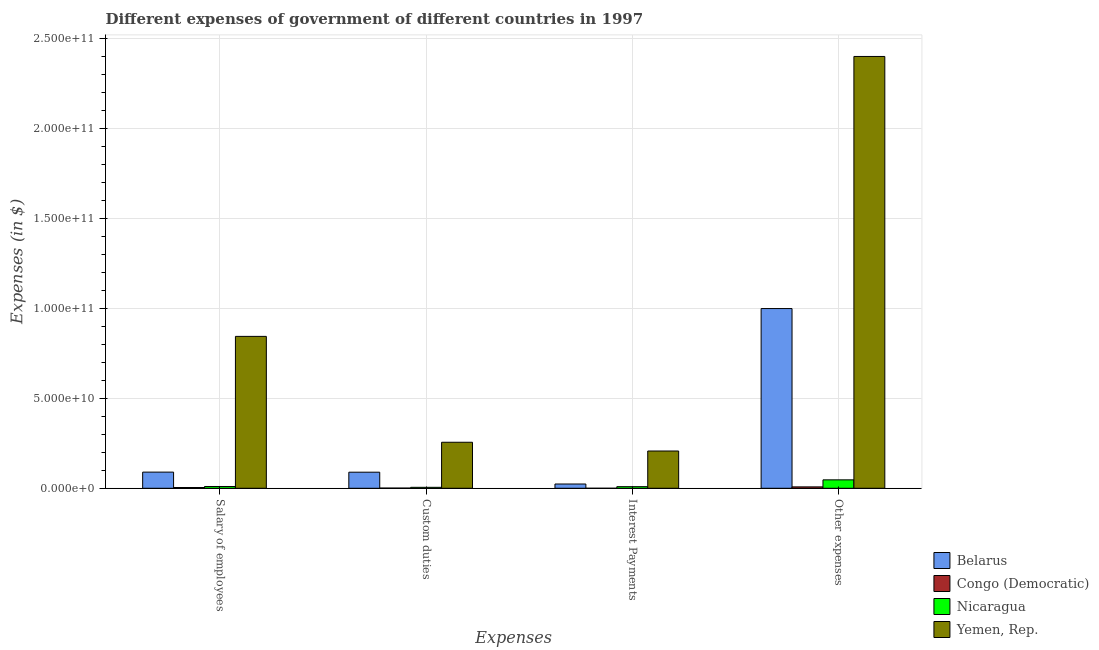Are the number of bars per tick equal to the number of legend labels?
Your answer should be very brief. Yes. What is the label of the 2nd group of bars from the left?
Offer a terse response. Custom duties. What is the amount spent on custom duties in Belarus?
Your answer should be very brief. 8.93e+09. Across all countries, what is the maximum amount spent on salary of employees?
Ensure brevity in your answer.  8.44e+1. Across all countries, what is the minimum amount spent on salary of employees?
Your answer should be very brief. 4.29e+08. In which country was the amount spent on salary of employees maximum?
Give a very brief answer. Yemen, Rep. In which country was the amount spent on salary of employees minimum?
Offer a very short reply. Congo (Democratic). What is the total amount spent on salary of employees in the graph?
Offer a terse response. 9.48e+1. What is the difference between the amount spent on other expenses in Nicaragua and that in Congo (Democratic)?
Offer a terse response. 3.91e+09. What is the difference between the amount spent on salary of employees in Congo (Democratic) and the amount spent on custom duties in Nicaragua?
Your answer should be compact. -1.08e+08. What is the average amount spent on salary of employees per country?
Ensure brevity in your answer.  2.37e+1. What is the difference between the amount spent on custom duties and amount spent on interest payments in Yemen, Rep.?
Offer a terse response. 4.86e+09. What is the ratio of the amount spent on custom duties in Nicaragua to that in Congo (Democratic)?
Your answer should be very brief. 5.1. Is the difference between the amount spent on salary of employees in Congo (Democratic) and Yemen, Rep. greater than the difference between the amount spent on custom duties in Congo (Democratic) and Yemen, Rep.?
Keep it short and to the point. No. What is the difference between the highest and the second highest amount spent on interest payments?
Offer a very short reply. 1.83e+1. What is the difference between the highest and the lowest amount spent on custom duties?
Give a very brief answer. 2.55e+1. What does the 3rd bar from the left in Salary of employees represents?
Make the answer very short. Nicaragua. What does the 4th bar from the right in Salary of employees represents?
Give a very brief answer. Belarus. Is it the case that in every country, the sum of the amount spent on salary of employees and amount spent on custom duties is greater than the amount spent on interest payments?
Your answer should be very brief. Yes. How many countries are there in the graph?
Offer a terse response. 4. Are the values on the major ticks of Y-axis written in scientific E-notation?
Offer a terse response. Yes. Does the graph contain any zero values?
Give a very brief answer. No. Does the graph contain grids?
Your answer should be compact. Yes. Where does the legend appear in the graph?
Provide a short and direct response. Bottom right. How many legend labels are there?
Your answer should be very brief. 4. How are the legend labels stacked?
Your answer should be compact. Vertical. What is the title of the graph?
Ensure brevity in your answer.  Different expenses of government of different countries in 1997. What is the label or title of the X-axis?
Make the answer very short. Expenses. What is the label or title of the Y-axis?
Your answer should be very brief. Expenses (in $). What is the Expenses (in $) in Belarus in Salary of employees?
Your answer should be compact. 8.98e+09. What is the Expenses (in $) of Congo (Democratic) in Salary of employees?
Your answer should be compact. 4.29e+08. What is the Expenses (in $) of Nicaragua in Salary of employees?
Provide a short and direct response. 9.96e+08. What is the Expenses (in $) in Yemen, Rep. in Salary of employees?
Provide a succinct answer. 8.44e+1. What is the Expenses (in $) of Belarus in Custom duties?
Provide a short and direct response. 8.93e+09. What is the Expenses (in $) in Congo (Democratic) in Custom duties?
Give a very brief answer. 1.05e+08. What is the Expenses (in $) in Nicaragua in Custom duties?
Provide a short and direct response. 5.37e+08. What is the Expenses (in $) of Yemen, Rep. in Custom duties?
Offer a terse response. 2.56e+1. What is the Expenses (in $) of Belarus in Interest Payments?
Provide a succinct answer. 2.37e+09. What is the Expenses (in $) in Nicaragua in Interest Payments?
Offer a terse response. 8.99e+08. What is the Expenses (in $) in Yemen, Rep. in Interest Payments?
Ensure brevity in your answer.  2.07e+1. What is the Expenses (in $) of Belarus in Other expenses?
Keep it short and to the point. 9.98e+1. What is the Expenses (in $) of Congo (Democratic) in Other expenses?
Provide a short and direct response. 7.77e+08. What is the Expenses (in $) in Nicaragua in Other expenses?
Offer a very short reply. 4.68e+09. What is the Expenses (in $) of Yemen, Rep. in Other expenses?
Keep it short and to the point. 2.40e+11. Across all Expenses, what is the maximum Expenses (in $) in Belarus?
Your answer should be compact. 9.98e+1. Across all Expenses, what is the maximum Expenses (in $) of Congo (Democratic)?
Provide a short and direct response. 7.77e+08. Across all Expenses, what is the maximum Expenses (in $) in Nicaragua?
Your response must be concise. 4.68e+09. Across all Expenses, what is the maximum Expenses (in $) of Yemen, Rep.?
Your answer should be very brief. 2.40e+11. Across all Expenses, what is the minimum Expenses (in $) of Belarus?
Give a very brief answer. 2.37e+09. Across all Expenses, what is the minimum Expenses (in $) of Congo (Democratic)?
Keep it short and to the point. 8.00e+05. Across all Expenses, what is the minimum Expenses (in $) of Nicaragua?
Offer a terse response. 5.37e+08. Across all Expenses, what is the minimum Expenses (in $) of Yemen, Rep.?
Your response must be concise. 2.07e+1. What is the total Expenses (in $) in Belarus in the graph?
Provide a succinct answer. 1.20e+11. What is the total Expenses (in $) of Congo (Democratic) in the graph?
Your response must be concise. 1.31e+09. What is the total Expenses (in $) of Nicaragua in the graph?
Provide a succinct answer. 7.12e+09. What is the total Expenses (in $) in Yemen, Rep. in the graph?
Make the answer very short. 3.71e+11. What is the difference between the Expenses (in $) in Belarus in Salary of employees and that in Custom duties?
Offer a terse response. 4.52e+07. What is the difference between the Expenses (in $) of Congo (Democratic) in Salary of employees and that in Custom duties?
Make the answer very short. 3.23e+08. What is the difference between the Expenses (in $) of Nicaragua in Salary of employees and that in Custom duties?
Make the answer very short. 4.59e+08. What is the difference between the Expenses (in $) in Yemen, Rep. in Salary of employees and that in Custom duties?
Ensure brevity in your answer.  5.88e+1. What is the difference between the Expenses (in $) of Belarus in Salary of employees and that in Interest Payments?
Your response must be concise. 6.61e+09. What is the difference between the Expenses (in $) in Congo (Democratic) in Salary of employees and that in Interest Payments?
Offer a terse response. 4.28e+08. What is the difference between the Expenses (in $) in Nicaragua in Salary of employees and that in Interest Payments?
Provide a short and direct response. 9.75e+07. What is the difference between the Expenses (in $) in Yemen, Rep. in Salary of employees and that in Interest Payments?
Offer a very short reply. 6.37e+1. What is the difference between the Expenses (in $) in Belarus in Salary of employees and that in Other expenses?
Your response must be concise. -9.09e+1. What is the difference between the Expenses (in $) of Congo (Democratic) in Salary of employees and that in Other expenses?
Provide a succinct answer. -3.48e+08. What is the difference between the Expenses (in $) of Nicaragua in Salary of employees and that in Other expenses?
Keep it short and to the point. -3.69e+09. What is the difference between the Expenses (in $) of Yemen, Rep. in Salary of employees and that in Other expenses?
Keep it short and to the point. -1.55e+11. What is the difference between the Expenses (in $) of Belarus in Custom duties and that in Interest Payments?
Offer a very short reply. 6.56e+09. What is the difference between the Expenses (in $) of Congo (Democratic) in Custom duties and that in Interest Payments?
Ensure brevity in your answer.  1.05e+08. What is the difference between the Expenses (in $) in Nicaragua in Custom duties and that in Interest Payments?
Ensure brevity in your answer.  -3.62e+08. What is the difference between the Expenses (in $) in Yemen, Rep. in Custom duties and that in Interest Payments?
Provide a succinct answer. 4.86e+09. What is the difference between the Expenses (in $) in Belarus in Custom duties and that in Other expenses?
Ensure brevity in your answer.  -9.09e+1. What is the difference between the Expenses (in $) of Congo (Democratic) in Custom duties and that in Other expenses?
Ensure brevity in your answer.  -6.71e+08. What is the difference between the Expenses (in $) of Nicaragua in Custom duties and that in Other expenses?
Your answer should be very brief. -4.15e+09. What is the difference between the Expenses (in $) of Yemen, Rep. in Custom duties and that in Other expenses?
Provide a succinct answer. -2.14e+11. What is the difference between the Expenses (in $) of Belarus in Interest Payments and that in Other expenses?
Your response must be concise. -9.75e+1. What is the difference between the Expenses (in $) of Congo (Democratic) in Interest Payments and that in Other expenses?
Provide a succinct answer. -7.76e+08. What is the difference between the Expenses (in $) in Nicaragua in Interest Payments and that in Other expenses?
Make the answer very short. -3.79e+09. What is the difference between the Expenses (in $) in Yemen, Rep. in Interest Payments and that in Other expenses?
Offer a very short reply. -2.19e+11. What is the difference between the Expenses (in $) of Belarus in Salary of employees and the Expenses (in $) of Congo (Democratic) in Custom duties?
Provide a short and direct response. 8.87e+09. What is the difference between the Expenses (in $) of Belarus in Salary of employees and the Expenses (in $) of Nicaragua in Custom duties?
Provide a short and direct response. 8.44e+09. What is the difference between the Expenses (in $) of Belarus in Salary of employees and the Expenses (in $) of Yemen, Rep. in Custom duties?
Your answer should be compact. -1.66e+1. What is the difference between the Expenses (in $) in Congo (Democratic) in Salary of employees and the Expenses (in $) in Nicaragua in Custom duties?
Your response must be concise. -1.08e+08. What is the difference between the Expenses (in $) of Congo (Democratic) in Salary of employees and the Expenses (in $) of Yemen, Rep. in Custom duties?
Make the answer very short. -2.51e+1. What is the difference between the Expenses (in $) of Nicaragua in Salary of employees and the Expenses (in $) of Yemen, Rep. in Custom duties?
Offer a very short reply. -2.46e+1. What is the difference between the Expenses (in $) in Belarus in Salary of employees and the Expenses (in $) in Congo (Democratic) in Interest Payments?
Make the answer very short. 8.98e+09. What is the difference between the Expenses (in $) of Belarus in Salary of employees and the Expenses (in $) of Nicaragua in Interest Payments?
Offer a terse response. 8.08e+09. What is the difference between the Expenses (in $) of Belarus in Salary of employees and the Expenses (in $) of Yemen, Rep. in Interest Payments?
Give a very brief answer. -1.17e+1. What is the difference between the Expenses (in $) in Congo (Democratic) in Salary of employees and the Expenses (in $) in Nicaragua in Interest Payments?
Your response must be concise. -4.70e+08. What is the difference between the Expenses (in $) of Congo (Democratic) in Salary of employees and the Expenses (in $) of Yemen, Rep. in Interest Payments?
Your answer should be compact. -2.03e+1. What is the difference between the Expenses (in $) in Nicaragua in Salary of employees and the Expenses (in $) in Yemen, Rep. in Interest Payments?
Offer a terse response. -1.97e+1. What is the difference between the Expenses (in $) in Belarus in Salary of employees and the Expenses (in $) in Congo (Democratic) in Other expenses?
Provide a short and direct response. 8.20e+09. What is the difference between the Expenses (in $) in Belarus in Salary of employees and the Expenses (in $) in Nicaragua in Other expenses?
Your answer should be compact. 4.29e+09. What is the difference between the Expenses (in $) in Belarus in Salary of employees and the Expenses (in $) in Yemen, Rep. in Other expenses?
Make the answer very short. -2.31e+11. What is the difference between the Expenses (in $) of Congo (Democratic) in Salary of employees and the Expenses (in $) of Nicaragua in Other expenses?
Provide a short and direct response. -4.26e+09. What is the difference between the Expenses (in $) of Congo (Democratic) in Salary of employees and the Expenses (in $) of Yemen, Rep. in Other expenses?
Offer a terse response. -2.39e+11. What is the difference between the Expenses (in $) in Nicaragua in Salary of employees and the Expenses (in $) in Yemen, Rep. in Other expenses?
Keep it short and to the point. -2.39e+11. What is the difference between the Expenses (in $) in Belarus in Custom duties and the Expenses (in $) in Congo (Democratic) in Interest Payments?
Make the answer very short. 8.93e+09. What is the difference between the Expenses (in $) of Belarus in Custom duties and the Expenses (in $) of Nicaragua in Interest Payments?
Make the answer very short. 8.04e+09. What is the difference between the Expenses (in $) in Belarus in Custom duties and the Expenses (in $) in Yemen, Rep. in Interest Payments?
Offer a terse response. -1.18e+1. What is the difference between the Expenses (in $) of Congo (Democratic) in Custom duties and the Expenses (in $) of Nicaragua in Interest Payments?
Make the answer very short. -7.93e+08. What is the difference between the Expenses (in $) of Congo (Democratic) in Custom duties and the Expenses (in $) of Yemen, Rep. in Interest Payments?
Give a very brief answer. -2.06e+1. What is the difference between the Expenses (in $) in Nicaragua in Custom duties and the Expenses (in $) in Yemen, Rep. in Interest Payments?
Your response must be concise. -2.02e+1. What is the difference between the Expenses (in $) of Belarus in Custom duties and the Expenses (in $) of Congo (Democratic) in Other expenses?
Provide a succinct answer. 8.16e+09. What is the difference between the Expenses (in $) in Belarus in Custom duties and the Expenses (in $) in Nicaragua in Other expenses?
Ensure brevity in your answer.  4.25e+09. What is the difference between the Expenses (in $) in Belarus in Custom duties and the Expenses (in $) in Yemen, Rep. in Other expenses?
Keep it short and to the point. -2.31e+11. What is the difference between the Expenses (in $) in Congo (Democratic) in Custom duties and the Expenses (in $) in Nicaragua in Other expenses?
Provide a succinct answer. -4.58e+09. What is the difference between the Expenses (in $) in Congo (Democratic) in Custom duties and the Expenses (in $) in Yemen, Rep. in Other expenses?
Keep it short and to the point. -2.40e+11. What is the difference between the Expenses (in $) of Nicaragua in Custom duties and the Expenses (in $) of Yemen, Rep. in Other expenses?
Give a very brief answer. -2.39e+11. What is the difference between the Expenses (in $) in Belarus in Interest Payments and the Expenses (in $) in Congo (Democratic) in Other expenses?
Give a very brief answer. 1.60e+09. What is the difference between the Expenses (in $) of Belarus in Interest Payments and the Expenses (in $) of Nicaragua in Other expenses?
Your answer should be very brief. -2.31e+09. What is the difference between the Expenses (in $) in Belarus in Interest Payments and the Expenses (in $) in Yemen, Rep. in Other expenses?
Your response must be concise. -2.37e+11. What is the difference between the Expenses (in $) in Congo (Democratic) in Interest Payments and the Expenses (in $) in Nicaragua in Other expenses?
Offer a very short reply. -4.68e+09. What is the difference between the Expenses (in $) of Congo (Democratic) in Interest Payments and the Expenses (in $) of Yemen, Rep. in Other expenses?
Your answer should be very brief. -2.40e+11. What is the difference between the Expenses (in $) of Nicaragua in Interest Payments and the Expenses (in $) of Yemen, Rep. in Other expenses?
Offer a terse response. -2.39e+11. What is the average Expenses (in $) of Belarus per Expenses?
Make the answer very short. 3.00e+1. What is the average Expenses (in $) of Congo (Democratic) per Expenses?
Offer a terse response. 3.28e+08. What is the average Expenses (in $) of Nicaragua per Expenses?
Offer a terse response. 1.78e+09. What is the average Expenses (in $) in Yemen, Rep. per Expenses?
Keep it short and to the point. 9.26e+1. What is the difference between the Expenses (in $) in Belarus and Expenses (in $) in Congo (Democratic) in Salary of employees?
Your answer should be very brief. 8.55e+09. What is the difference between the Expenses (in $) of Belarus and Expenses (in $) of Nicaragua in Salary of employees?
Make the answer very short. 7.98e+09. What is the difference between the Expenses (in $) in Belarus and Expenses (in $) in Yemen, Rep. in Salary of employees?
Provide a succinct answer. -7.54e+1. What is the difference between the Expenses (in $) of Congo (Democratic) and Expenses (in $) of Nicaragua in Salary of employees?
Make the answer very short. -5.67e+08. What is the difference between the Expenses (in $) in Congo (Democratic) and Expenses (in $) in Yemen, Rep. in Salary of employees?
Your answer should be very brief. -8.39e+1. What is the difference between the Expenses (in $) in Nicaragua and Expenses (in $) in Yemen, Rep. in Salary of employees?
Make the answer very short. -8.34e+1. What is the difference between the Expenses (in $) of Belarus and Expenses (in $) of Congo (Democratic) in Custom duties?
Your response must be concise. 8.83e+09. What is the difference between the Expenses (in $) of Belarus and Expenses (in $) of Nicaragua in Custom duties?
Ensure brevity in your answer.  8.40e+09. What is the difference between the Expenses (in $) in Belarus and Expenses (in $) in Yemen, Rep. in Custom duties?
Offer a terse response. -1.66e+1. What is the difference between the Expenses (in $) in Congo (Democratic) and Expenses (in $) in Nicaragua in Custom duties?
Provide a succinct answer. -4.31e+08. What is the difference between the Expenses (in $) of Congo (Democratic) and Expenses (in $) of Yemen, Rep. in Custom duties?
Offer a very short reply. -2.55e+1. What is the difference between the Expenses (in $) in Nicaragua and Expenses (in $) in Yemen, Rep. in Custom duties?
Your response must be concise. -2.50e+1. What is the difference between the Expenses (in $) of Belarus and Expenses (in $) of Congo (Democratic) in Interest Payments?
Provide a short and direct response. 2.37e+09. What is the difference between the Expenses (in $) in Belarus and Expenses (in $) in Nicaragua in Interest Payments?
Keep it short and to the point. 1.48e+09. What is the difference between the Expenses (in $) in Belarus and Expenses (in $) in Yemen, Rep. in Interest Payments?
Your answer should be very brief. -1.83e+1. What is the difference between the Expenses (in $) of Congo (Democratic) and Expenses (in $) of Nicaragua in Interest Payments?
Ensure brevity in your answer.  -8.98e+08. What is the difference between the Expenses (in $) of Congo (Democratic) and Expenses (in $) of Yemen, Rep. in Interest Payments?
Provide a short and direct response. -2.07e+1. What is the difference between the Expenses (in $) in Nicaragua and Expenses (in $) in Yemen, Rep. in Interest Payments?
Ensure brevity in your answer.  -1.98e+1. What is the difference between the Expenses (in $) in Belarus and Expenses (in $) in Congo (Democratic) in Other expenses?
Offer a terse response. 9.91e+1. What is the difference between the Expenses (in $) of Belarus and Expenses (in $) of Nicaragua in Other expenses?
Offer a terse response. 9.51e+1. What is the difference between the Expenses (in $) in Belarus and Expenses (in $) in Yemen, Rep. in Other expenses?
Provide a short and direct response. -1.40e+11. What is the difference between the Expenses (in $) of Congo (Democratic) and Expenses (in $) of Nicaragua in Other expenses?
Offer a very short reply. -3.91e+09. What is the difference between the Expenses (in $) of Congo (Democratic) and Expenses (in $) of Yemen, Rep. in Other expenses?
Offer a very short reply. -2.39e+11. What is the difference between the Expenses (in $) in Nicaragua and Expenses (in $) in Yemen, Rep. in Other expenses?
Your response must be concise. -2.35e+11. What is the ratio of the Expenses (in $) in Congo (Democratic) in Salary of employees to that in Custom duties?
Offer a terse response. 4.07. What is the ratio of the Expenses (in $) in Nicaragua in Salary of employees to that in Custom duties?
Offer a terse response. 1.86. What is the ratio of the Expenses (in $) in Yemen, Rep. in Salary of employees to that in Custom duties?
Your answer should be very brief. 3.3. What is the ratio of the Expenses (in $) of Belarus in Salary of employees to that in Interest Payments?
Offer a very short reply. 3.78. What is the ratio of the Expenses (in $) in Congo (Democratic) in Salary of employees to that in Interest Payments?
Your answer should be compact. 535.95. What is the ratio of the Expenses (in $) of Nicaragua in Salary of employees to that in Interest Payments?
Provide a succinct answer. 1.11. What is the ratio of the Expenses (in $) of Yemen, Rep. in Salary of employees to that in Interest Payments?
Provide a short and direct response. 4.07. What is the ratio of the Expenses (in $) of Belarus in Salary of employees to that in Other expenses?
Make the answer very short. 0.09. What is the ratio of the Expenses (in $) of Congo (Democratic) in Salary of employees to that in Other expenses?
Make the answer very short. 0.55. What is the ratio of the Expenses (in $) of Nicaragua in Salary of employees to that in Other expenses?
Your answer should be compact. 0.21. What is the ratio of the Expenses (in $) of Yemen, Rep. in Salary of employees to that in Other expenses?
Your response must be concise. 0.35. What is the ratio of the Expenses (in $) of Belarus in Custom duties to that in Interest Payments?
Ensure brevity in your answer.  3.76. What is the ratio of the Expenses (in $) in Congo (Democratic) in Custom duties to that in Interest Payments?
Offer a very short reply. 131.68. What is the ratio of the Expenses (in $) of Nicaragua in Custom duties to that in Interest Payments?
Offer a very short reply. 0.6. What is the ratio of the Expenses (in $) of Yemen, Rep. in Custom duties to that in Interest Payments?
Offer a terse response. 1.23. What is the ratio of the Expenses (in $) of Belarus in Custom duties to that in Other expenses?
Provide a short and direct response. 0.09. What is the ratio of the Expenses (in $) in Congo (Democratic) in Custom duties to that in Other expenses?
Make the answer very short. 0.14. What is the ratio of the Expenses (in $) in Nicaragua in Custom duties to that in Other expenses?
Your response must be concise. 0.11. What is the ratio of the Expenses (in $) of Yemen, Rep. in Custom duties to that in Other expenses?
Provide a short and direct response. 0.11. What is the ratio of the Expenses (in $) in Belarus in Interest Payments to that in Other expenses?
Provide a succinct answer. 0.02. What is the ratio of the Expenses (in $) of Congo (Democratic) in Interest Payments to that in Other expenses?
Your response must be concise. 0. What is the ratio of the Expenses (in $) in Nicaragua in Interest Payments to that in Other expenses?
Ensure brevity in your answer.  0.19. What is the ratio of the Expenses (in $) of Yemen, Rep. in Interest Payments to that in Other expenses?
Offer a terse response. 0.09. What is the difference between the highest and the second highest Expenses (in $) in Belarus?
Your answer should be compact. 9.09e+1. What is the difference between the highest and the second highest Expenses (in $) in Congo (Democratic)?
Provide a succinct answer. 3.48e+08. What is the difference between the highest and the second highest Expenses (in $) in Nicaragua?
Offer a terse response. 3.69e+09. What is the difference between the highest and the second highest Expenses (in $) of Yemen, Rep.?
Your answer should be very brief. 1.55e+11. What is the difference between the highest and the lowest Expenses (in $) in Belarus?
Ensure brevity in your answer.  9.75e+1. What is the difference between the highest and the lowest Expenses (in $) of Congo (Democratic)?
Provide a short and direct response. 7.76e+08. What is the difference between the highest and the lowest Expenses (in $) of Nicaragua?
Ensure brevity in your answer.  4.15e+09. What is the difference between the highest and the lowest Expenses (in $) in Yemen, Rep.?
Offer a very short reply. 2.19e+11. 